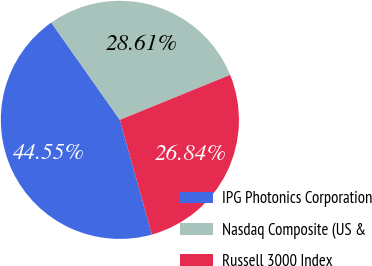Convert chart. <chart><loc_0><loc_0><loc_500><loc_500><pie_chart><fcel>IPG Photonics Corporation<fcel>Nasdaq Composite (US &<fcel>Russell 3000 Index<nl><fcel>44.55%<fcel>28.61%<fcel>26.84%<nl></chart> 